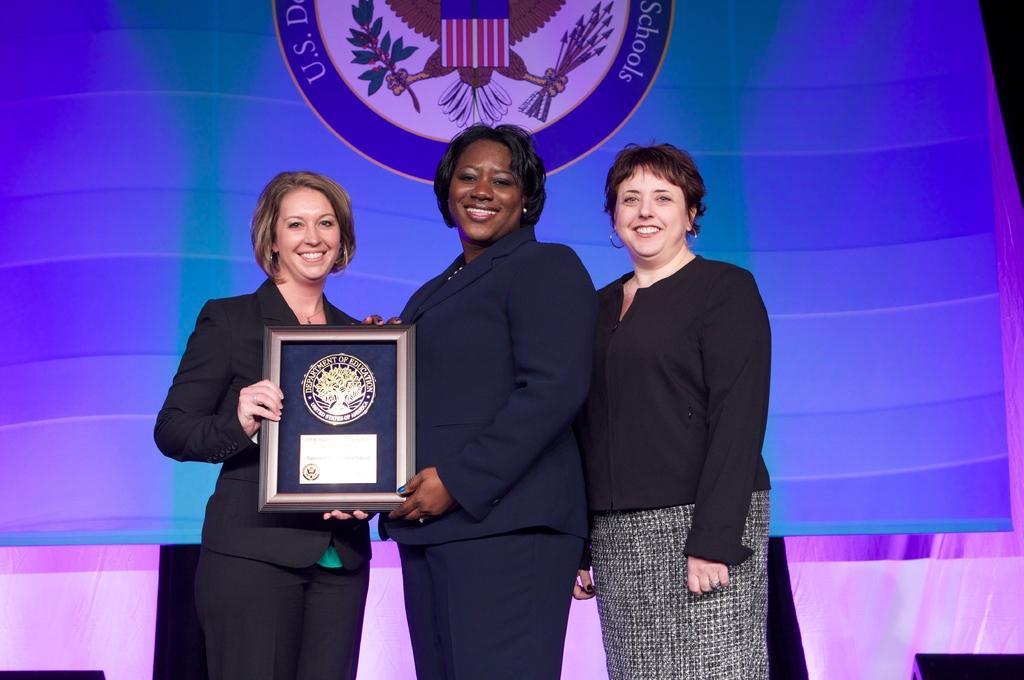In one or two sentences, can you explain what this image depicts? In the center of the image we can see women standing on the dais and holding frame. In the background we can see screen and curtain. 